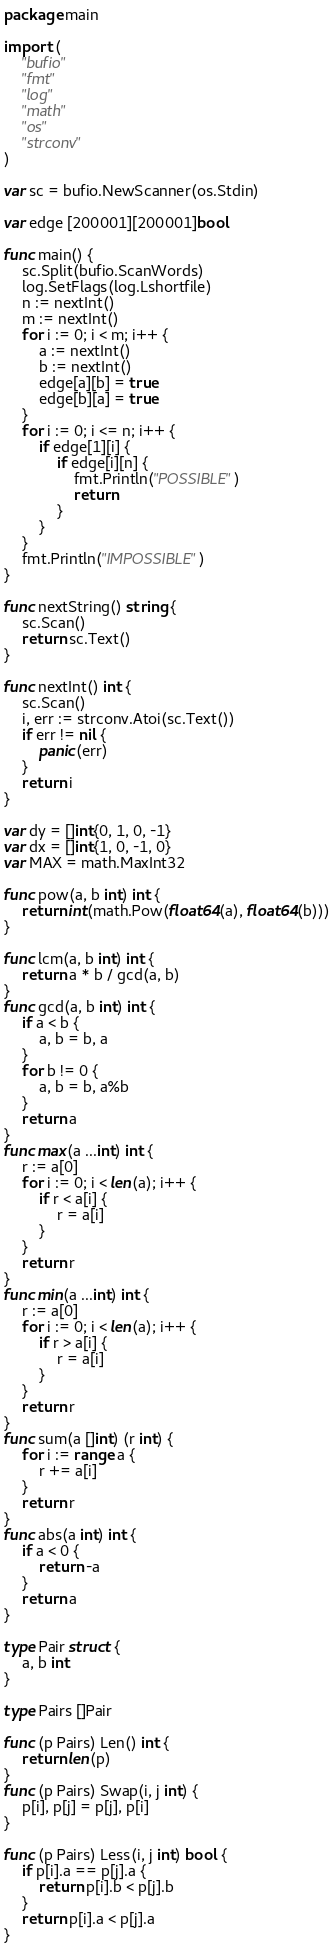Convert code to text. <code><loc_0><loc_0><loc_500><loc_500><_Go_>package main

import (
	"bufio"
	"fmt"
	"log"
	"math"
	"os"
	"strconv"
)

var sc = bufio.NewScanner(os.Stdin)

var edge [200001][200001]bool

func main() {
	sc.Split(bufio.ScanWords)
	log.SetFlags(log.Lshortfile)
	n := nextInt()
	m := nextInt()
	for i := 0; i < m; i++ {
		a := nextInt()
		b := nextInt()
		edge[a][b] = true
		edge[b][a] = true
	}
	for i := 0; i <= n; i++ {
		if edge[1][i] {
			if edge[i][n] {
				fmt.Println("POSSIBLE")
				return
			}
		}
	}
	fmt.Println("IMPOSSIBLE")
}

func nextString() string {
	sc.Scan()
	return sc.Text()
}

func nextInt() int {
	sc.Scan()
	i, err := strconv.Atoi(sc.Text())
	if err != nil {
		panic(err)
	}
	return i
}

var dy = []int{0, 1, 0, -1}
var dx = []int{1, 0, -1, 0}
var MAX = math.MaxInt32

func pow(a, b int) int {
	return int(math.Pow(float64(a), float64(b)))
}

func lcm(a, b int) int {
	return a * b / gcd(a, b)
}
func gcd(a, b int) int {
	if a < b {
		a, b = b, a
	}
	for b != 0 {
		a, b = b, a%b
	}
	return a
}
func max(a ...int) int {
	r := a[0]
	for i := 0; i < len(a); i++ {
		if r < a[i] {
			r = a[i]
		}
	}
	return r
}
func min(a ...int) int {
	r := a[0]
	for i := 0; i < len(a); i++ {
		if r > a[i] {
			r = a[i]
		}
	}
	return r
}
func sum(a []int) (r int) {
	for i := range a {
		r += a[i]
	}
	return r
}
func abs(a int) int {
	if a < 0 {
		return -a
	}
	return a
}

type Pair struct {
	a, b int
}

type Pairs []Pair

func (p Pairs) Len() int {
	return len(p)
}
func (p Pairs) Swap(i, j int) {
	p[i], p[j] = p[j], p[i]
}

func (p Pairs) Less(i, j int) bool {
	if p[i].a == p[j].a {
		return p[i].b < p[j].b
	}
	return p[i].a < p[j].a
}
</code> 